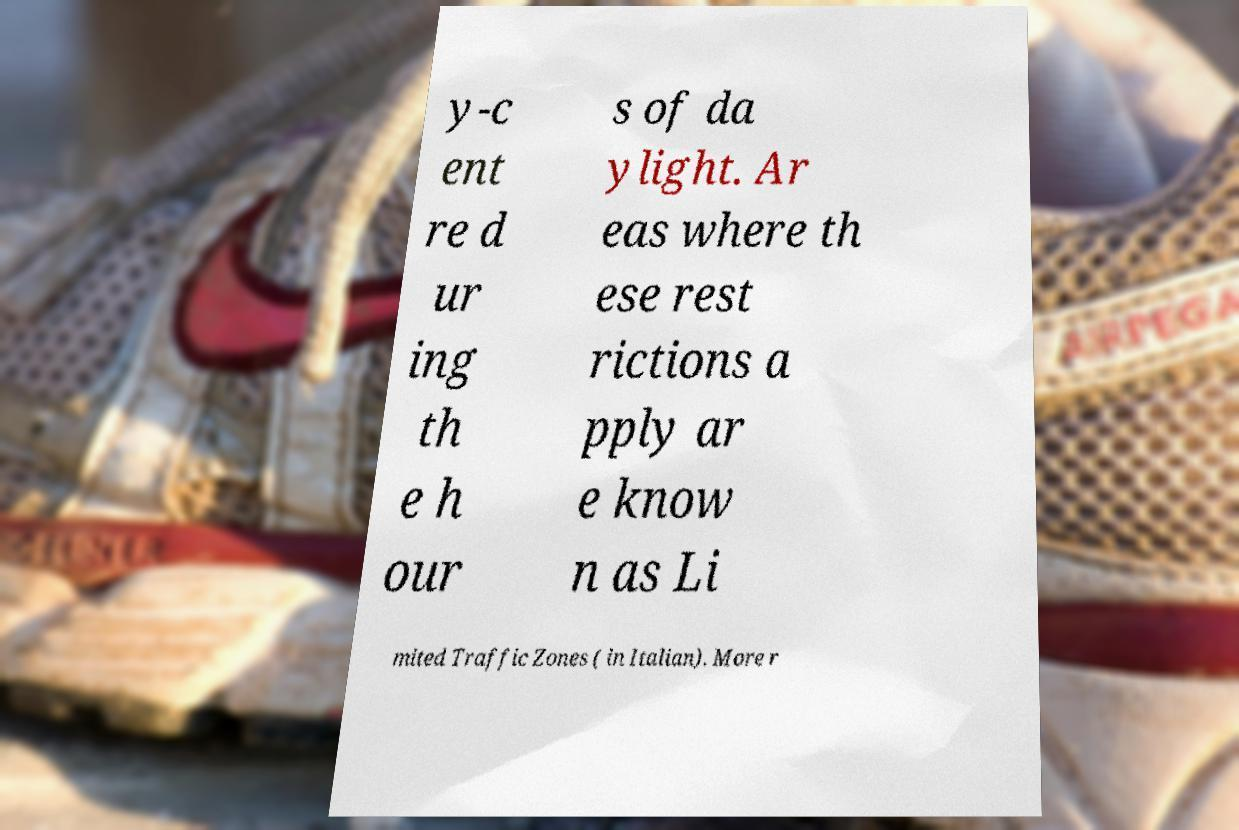Can you read and provide the text displayed in the image?This photo seems to have some interesting text. Can you extract and type it out for me? y-c ent re d ur ing th e h our s of da ylight. Ar eas where th ese rest rictions a pply ar e know n as Li mited Traffic Zones ( in Italian). More r 